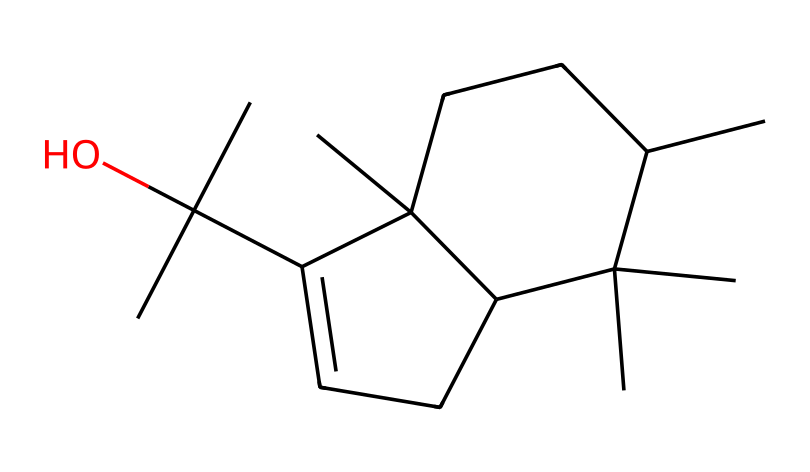What is the primary functional group present in patchouli oil? Analyzing the provided SMILES, we can identify the hydroxyl (-OH) group attached to one of the carbon atoms, which indicates the presence of an alcohol functional group. This group is characteristic of many natural fragrances, including patchouli oil.
Answer: alcohol How many carbon atoms are in the patchouli oil structure? By examining the SMILES representation closely, we count a total of 15 carbon atoms present in the entire compound structure. This includes both the branched and cyclic components of the molecule.
Answer: 15 How many rings are there in the chemical structure of patchouli oil? Upon reviewing the chemical layout depicted by the SMILES, I notice that there are two distinct rings present in the structure. One can visualize them by observing the interconnected cyclic arrangements of the carbon atoms.
Answer: 2 What type of bonding is primarily observed in the patchouli oil structure? The SMILES representation shows a combination of single and double bonds, but primarily, it indicates many C-C and C-H single bonds, which are typical in organic compounds. This suggests a standard covalent bonding nature in its structure.
Answer: covalent Is patchouli oil considered a polar or nonpolar compound? To determine the polarity, we look at the overall molecular structure. Given the presence of the hydroxyl group, which is polar, and the large hydrocarbon framework, it suggests the compound has both polar and nonpolar characteristics. However, the substantial nonpolar region predominates, designating it largely as nonpolar overall.
Answer: nonpolar What is the approximate molecular weight of patchouli oil based on its chemical composition? By calculating the molecular weight based on the 15 carbon (C), 26 hydrogen (H), and 1 oxygen (O) atoms present, the approximate molecular weight can be determined through summing the atomic weights of these elements (C=12, H=1, O=16). The total comes close to 218 grams per mole.
Answer: 218 